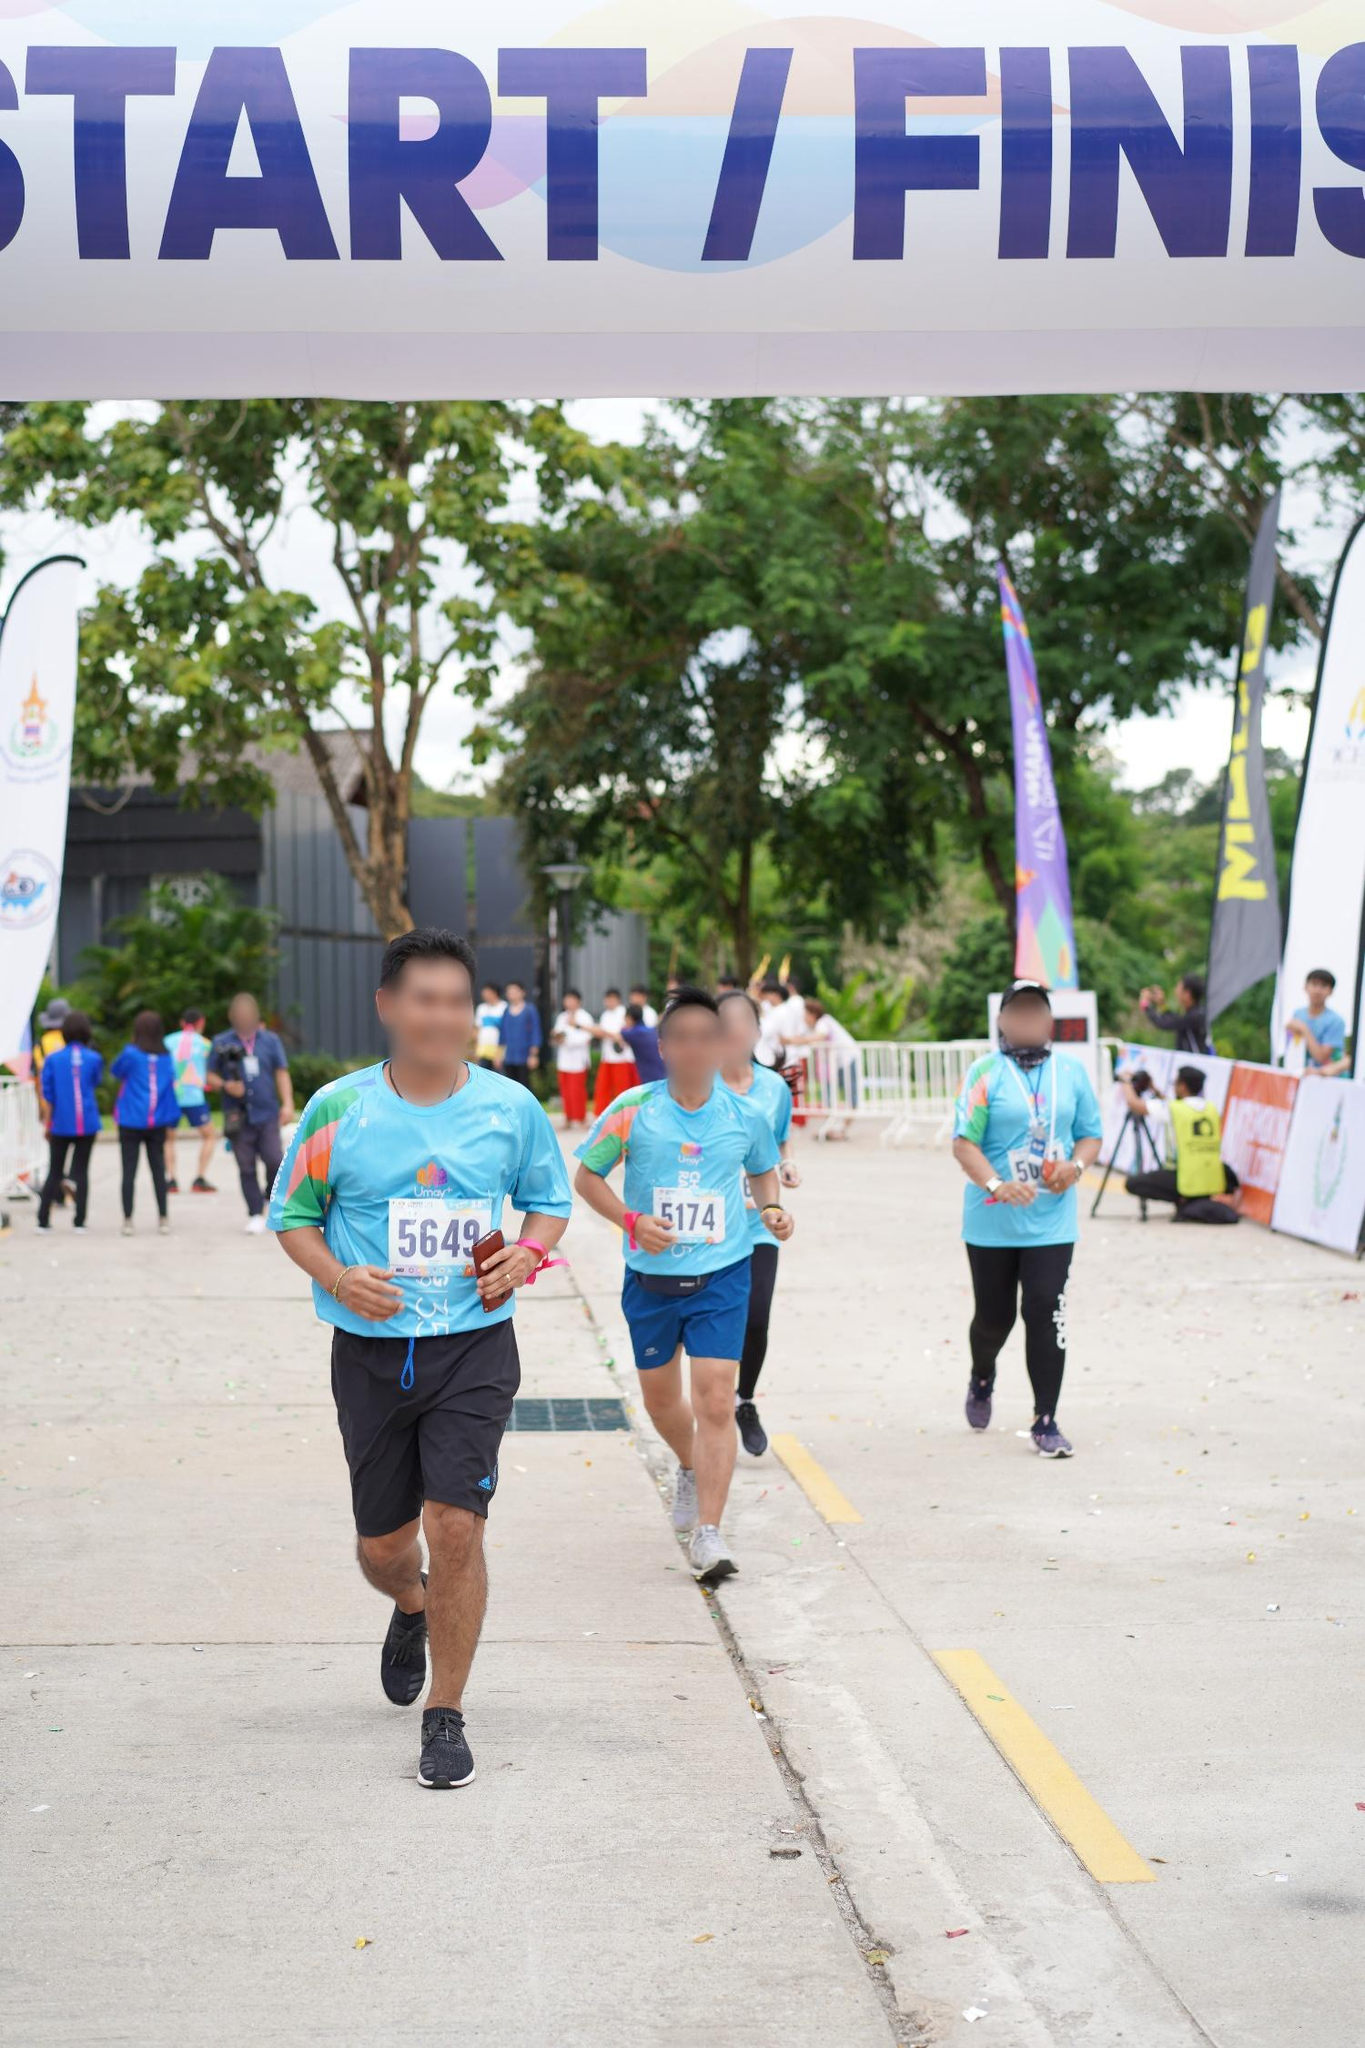Imagine the runners are actually characters in a fantastical realm where this race is part of a grand quest. What could be at stake? In a fantastical realm, the race could be part of a grand quest where each runner is a hero competing to secure a magical artifact at the finish line. The numbers on their shirts could symbolize their unique abilities or strengths needed to overcome various challenges along the race. The 'START/FINISH' line could be the boundary to a new reality, a portal to another world. The stakes could be incredibly high, such as saving their kingdom from an impending doom or restoring peace to their war-torn land. Behind them, mythical creatures could be cheering them on, and the serene trees could be ancient guardians providing protection and guidance. Describe a realistic scenario where this image takes place at a charity event. Who are the participants and what cause are they supporting? This image might depict a charity marathon aiming to raise funds for cancer research. The participants are people from diverse backgrounds—including cancer survivors, supportive family members, medical professionals, and community supporters—all united for a common cause. The blue shirts signify their participation and commitment to fighting cancer, with each number representing an individual story and journey. The event is organized to raise awareness, foster community spirit, and generate donations to support ongoing research and patient care. The serene backdrop reflects the hope and resilience of everyone involved, symbolizing the strength derived from unity and purpose. Imagine that one of the runners in this race is secretly a renowned marathon champion running incognito. Write a long narrative that describes how the race unfolds for this runner. In this charity race, one runner stands out—number 5649, a renowned marathon champion running incognito. Dressed just like any other participant, his identity hidden beneath the humble blue shirt, he blends into the crowd effortlessly. As the race begins, he paces himself, a seasoned strategy honed from years of competitive training. He gently accelerates as the race progresses, his eyes scanning the course, calculating every move. Despite the casual nature of the event, the thrill of competition is alive within him. He feels the familiar rush of adrenaline, his heart pumping to the rhythm of his steps. Observing the other racers, he offers support and encouragement, embodying the spirit of the charity event. However, as he nears the finish line, memories of past victories flood his mind, and he can’t help but push his limits slightly. The finish line in sight, he surges ahead with a burst of speed, crossing triumphantly but modestly, ensuring he doesn't overshadow the joy of others. Reveling in the accomplishment not just for himself, but for the cause, he blends back into the crowd, satisfied with contributing to a greater good while staying true to his passion. 